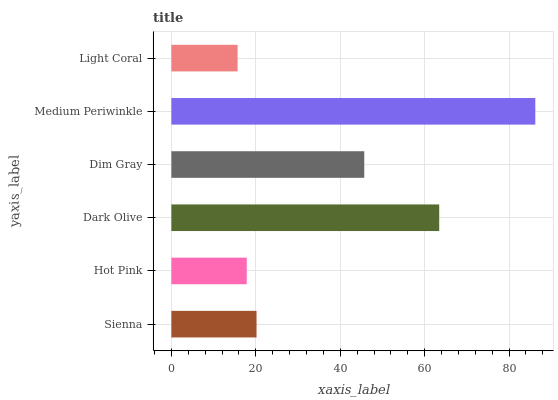Is Light Coral the minimum?
Answer yes or no. Yes. Is Medium Periwinkle the maximum?
Answer yes or no. Yes. Is Hot Pink the minimum?
Answer yes or no. No. Is Hot Pink the maximum?
Answer yes or no. No. Is Sienna greater than Hot Pink?
Answer yes or no. Yes. Is Hot Pink less than Sienna?
Answer yes or no. Yes. Is Hot Pink greater than Sienna?
Answer yes or no. No. Is Sienna less than Hot Pink?
Answer yes or no. No. Is Dim Gray the high median?
Answer yes or no. Yes. Is Sienna the low median?
Answer yes or no. Yes. Is Hot Pink the high median?
Answer yes or no. No. Is Dark Olive the low median?
Answer yes or no. No. 